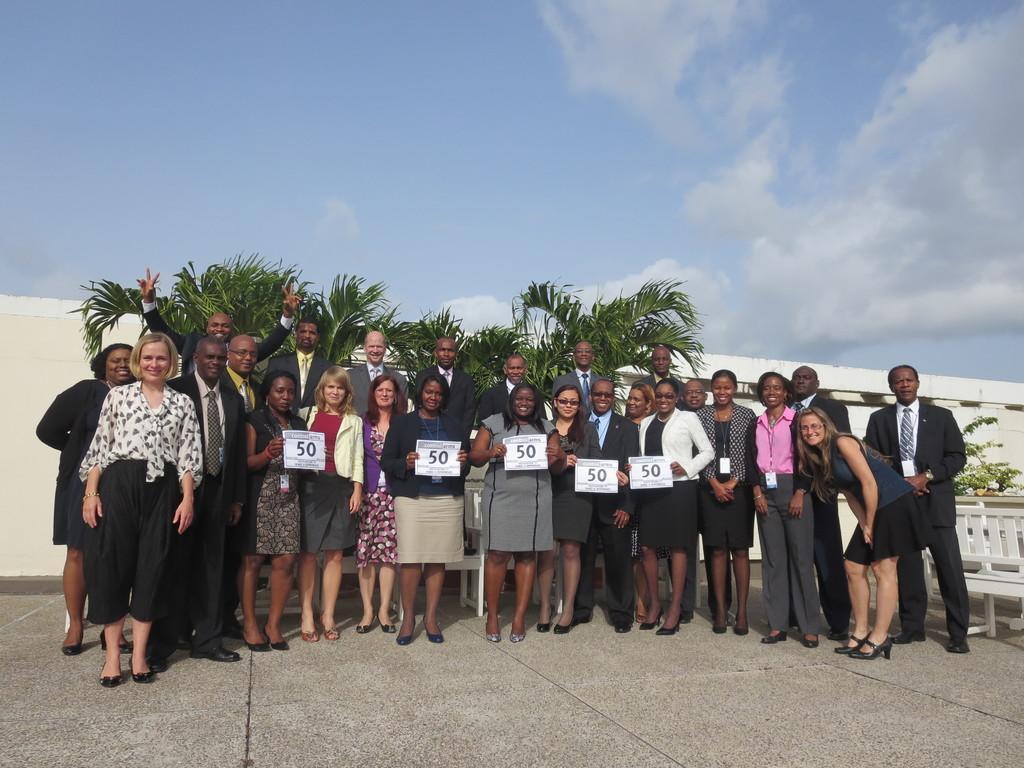Could you give a brief overview of what you see in this image? There are group of people standing and posing for the photo,some of the women are holding a sheet in their hands and there is a wall behind the people and in front of the wall there are some trees. 